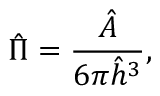<formula> <loc_0><loc_0><loc_500><loc_500>\hat { \Pi } = \frac { \hat { A } } { 6 \pi \hat { h } ^ { 3 } } ,</formula> 